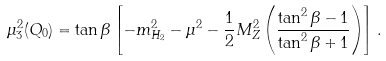Convert formula to latex. <formula><loc_0><loc_0><loc_500><loc_500>\mu _ { 3 } ^ { 2 } ( Q _ { 0 } ) = \tan \beta \left [ - m _ { H _ { 2 } } ^ { 2 } - \mu ^ { 2 } - \frac { 1 } { 2 } M _ { Z } ^ { 2 } \left ( \frac { \tan ^ { 2 } \beta - 1 } { \tan ^ { 2 } \beta + 1 } \right ) \right ] .</formula> 